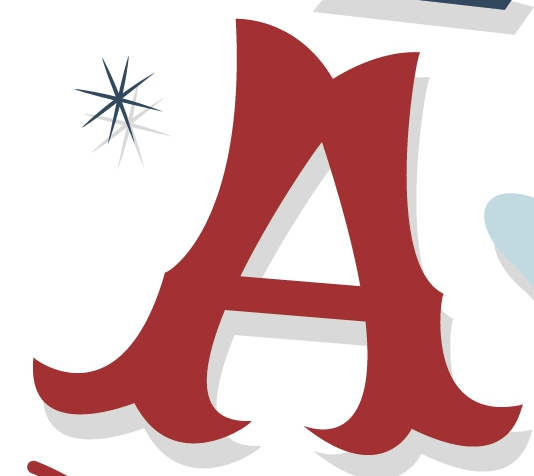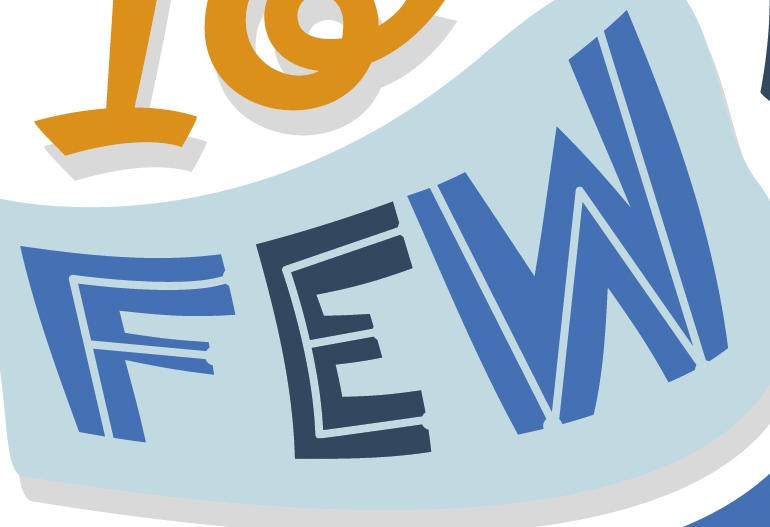Transcribe the words shown in these images in order, separated by a semicolon. A; FEW 